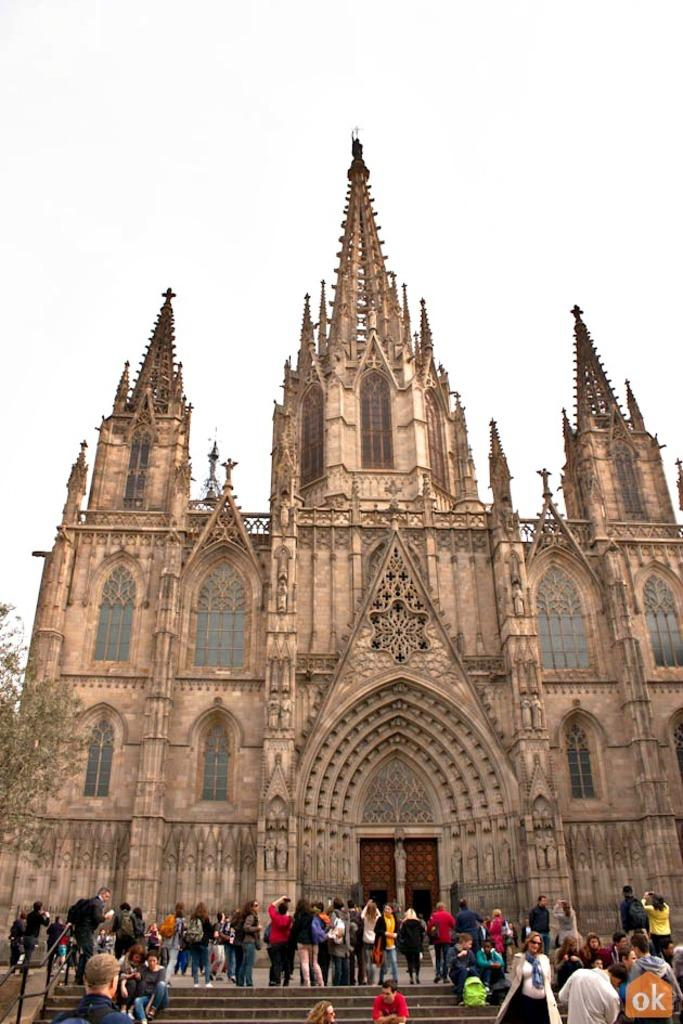What is located at the bottom of the image? There is a group of people at the bottom of the image. What is the main structure in the middle of the image? There is a very big building in the middle of the image. What type of vegetation is on the left side of the image? There is a tree on the left side of the image. What is visible at the top of the image? The sky is visible at the top of the image. Can you see any steam coming from the tree in the image? There is no steam present in the image; it features a tree, a group of people, a big building, and the sky. What type of muscle is visible on the building in the image? There is no muscle present in the image; it features a tree, a group of people, a big building, and the sky. 